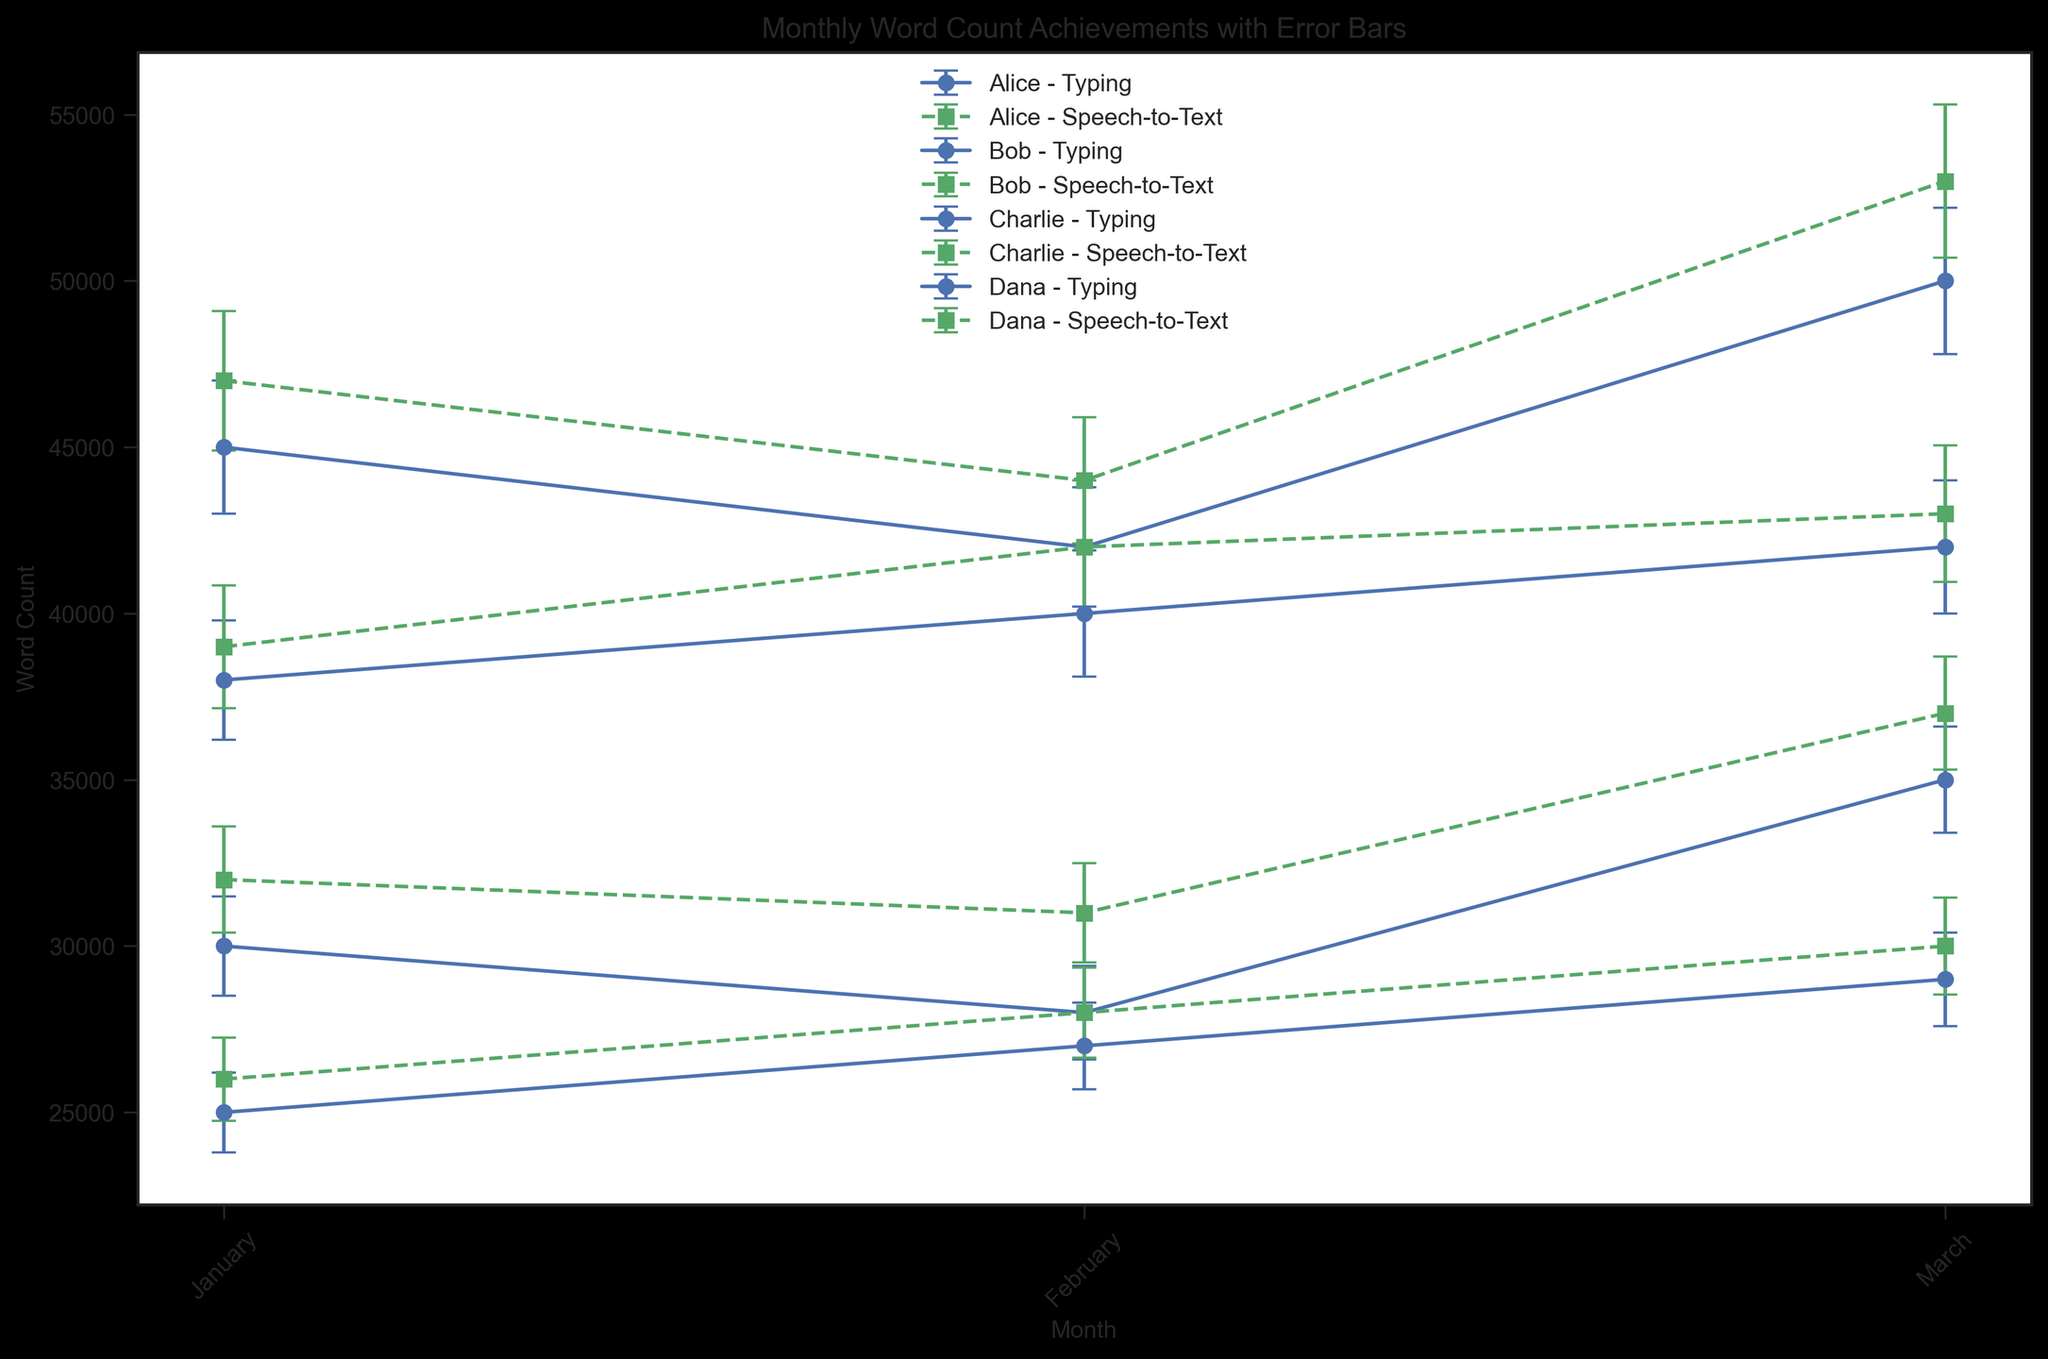What month did Alice achieve the highest word count using Speech-to-Text? Alice's highest word count using Speech-to-Text is represented by the highest point in the green line with 's' markers assigned to Alice. By visually inspecting the figure, we can see that Alice's highest word count using Speech-to-Text occurs in March.
Answer: March How does Bob's word count in February compare between Typing and Speech-to-Text? To compare Bob's word count for February, look at the two points for Bob in February: one for Typing (blue line with 'o' markers) and one for Speech-to-Text (green line with 's' markers). Bob's word count for Typing in February is 28,000, while for Speech-to-Text it is 31,000. Speech-to-Text is higher.
Answer: Speech-to-Text is higher Who has the least variation in word count using Speech-to-Text across the three months, and what is their average standard deviation? The variation in word count is represented by the error bars. To find the least variation, compare the lengths of green error bars for each member. Dana has the shortest error bars for Speech-to-Text. Calculate the average of her standard deviations: (1250 + 1350 + 1450) / 3 = 1350.
Answer: Dana, 1350 Which member shows the greatest increase in word count from January to March using Typing? Look at the blue line with 'o' markers for each member to calculate the difference between January and March. Subtract January's word count from March's to find the increase. Charlie's word count increases from 38,000 to 42,000, so the increase is 4,000 words. This is the highest among all members.
Answer: Charlie Does any member have a higher word count with Typing than with Speech-to-Text in March? Compare the March data points for Typing (blue line with 'o' markers) and Speech-to-Text (green line with 's' markers) for each member. For Alice, Bob, Charlie, and Dana, their word counts are higher in Speech-to-Text for March. Thus, the answer is no member has a higher word count with Typing in March.
Answer: No What is the average word count for Charlie in February across both conditions? Add Charlie's Typing and Speech-to-Text word counts in February and divide by 2. For Typing, it is 40,000; for Speech-to-Text, it is 42,000. The average is (40,000 + 42,000) / 2 = 41,000.
Answer: 41,000 How does Dana's word count change from January to February using Typing? Look at Dana's word count for Typing in January and February. In January, it is 25,000, and in February, it is 27,000. The change is 27,000 - 25,000 = 2,000 increase.
Answer: 2,000 increase Which month shows the largest overall variation in word count for all members using Speech-to-Text? Look at the lengths of all green error bars for January, February, and March. Visually, the error bars' lengths are considered for comparison. March shows the largest overall variation as it has more extended error bars for most members.
Answer: March Which member has the highest word count standard deviation using Typing, and what is it? Identify the highest standard deviation among the Typing condition by comparing the error bars' lengths in blue. Alice in March has the highest standard deviation, which is 2200.
Answer: Alice, 2200 